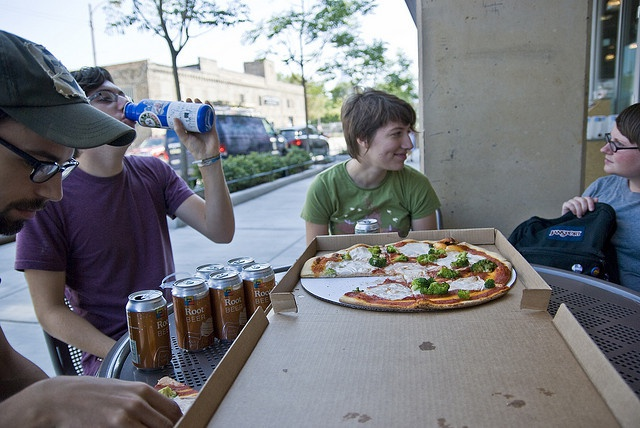Describe the objects in this image and their specific colors. I can see dining table in lavender, darkgray, gray, and black tones, people in lavender, black, gray, and navy tones, people in lavender, black, gray, and darkblue tones, people in lavender, gray, black, darkgreen, and darkgray tones, and pizza in lavender, darkgray, lightgray, brown, and olive tones in this image. 